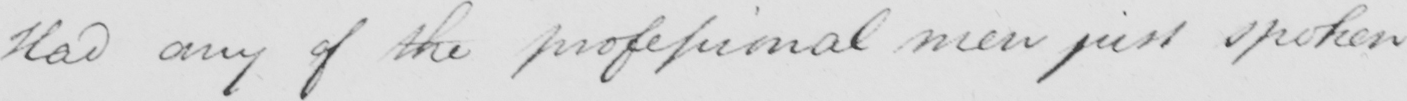Please transcribe the handwritten text in this image. Had any of the professional men just spoken 